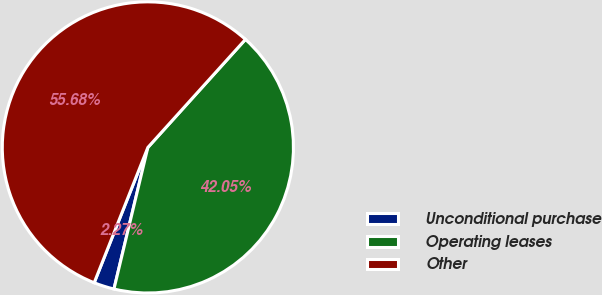Convert chart to OTSL. <chart><loc_0><loc_0><loc_500><loc_500><pie_chart><fcel>Unconditional purchase<fcel>Operating leases<fcel>Other<nl><fcel>2.27%<fcel>42.05%<fcel>55.68%<nl></chart> 